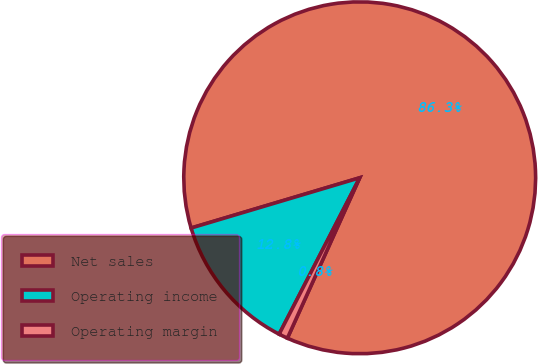Convert chart to OTSL. <chart><loc_0><loc_0><loc_500><loc_500><pie_chart><fcel>Net sales<fcel>Operating income<fcel>Operating margin<nl><fcel>86.35%<fcel>12.82%<fcel>0.83%<nl></chart> 